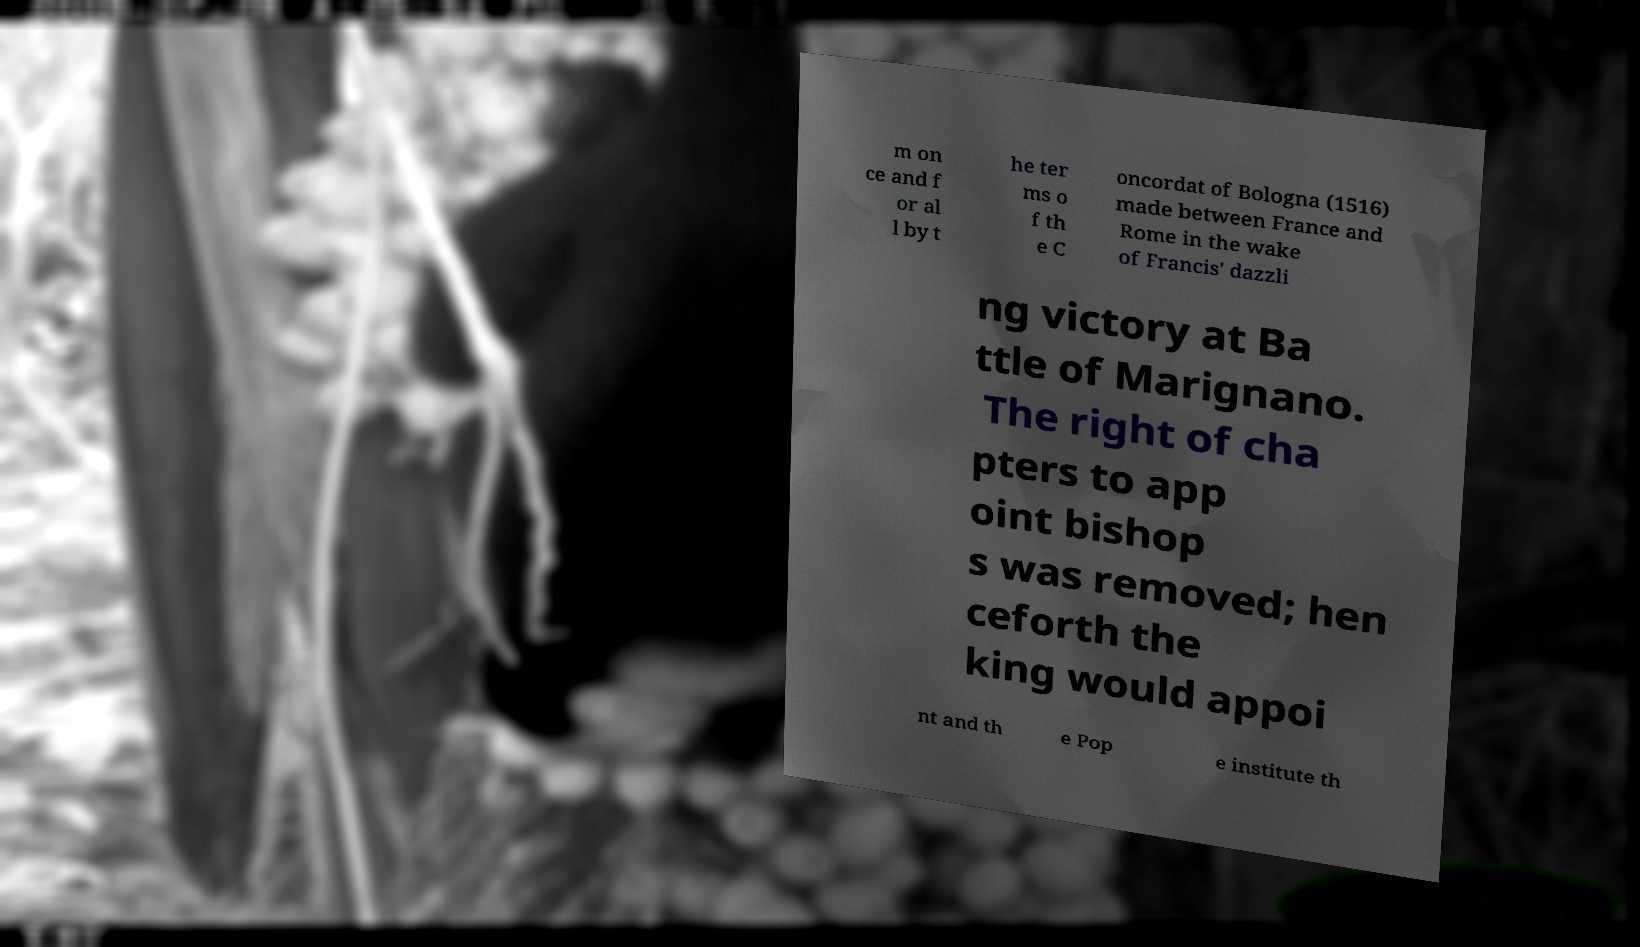Can you read and provide the text displayed in the image?This photo seems to have some interesting text. Can you extract and type it out for me? m on ce and f or al l by t he ter ms o f th e C oncordat of Bologna (1516) made between France and Rome in the wake of Francis' dazzli ng victory at Ba ttle of Marignano. The right of cha pters to app oint bishop s was removed; hen ceforth the king would appoi nt and th e Pop e institute th 